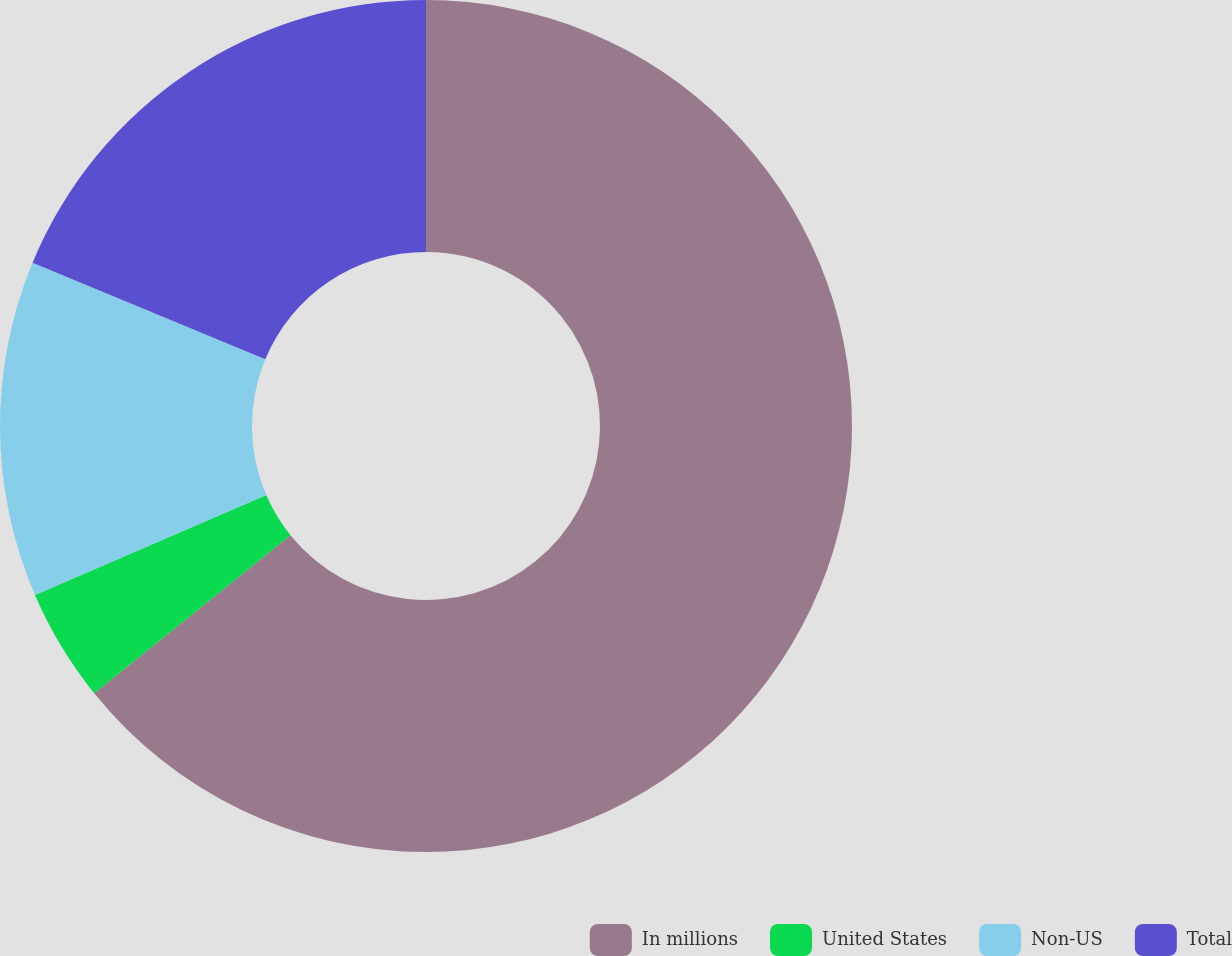Convert chart to OTSL. <chart><loc_0><loc_0><loc_500><loc_500><pie_chart><fcel>In millions<fcel>United States<fcel>Non-US<fcel>Total<nl><fcel>64.21%<fcel>4.3%<fcel>12.75%<fcel>18.74%<nl></chart> 